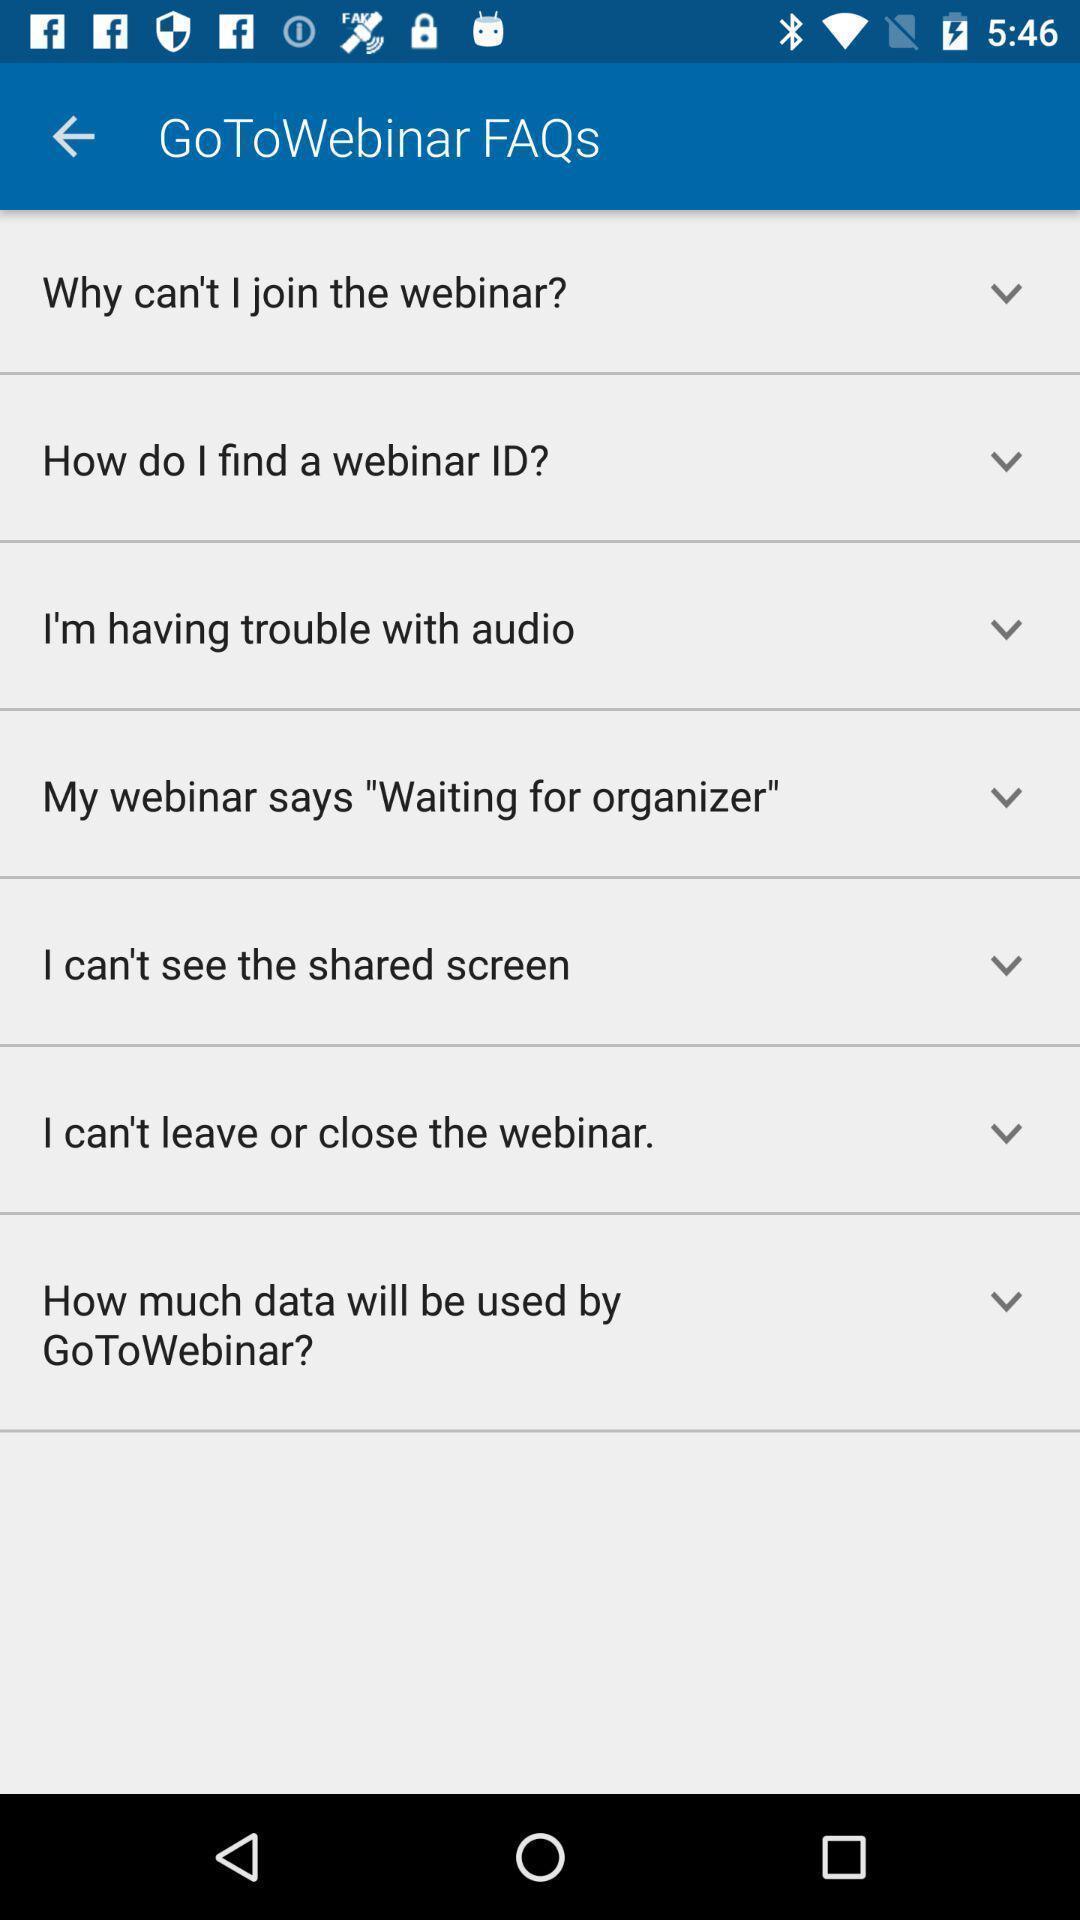Provide a textual representation of this image. Page showing faqs on an app. 